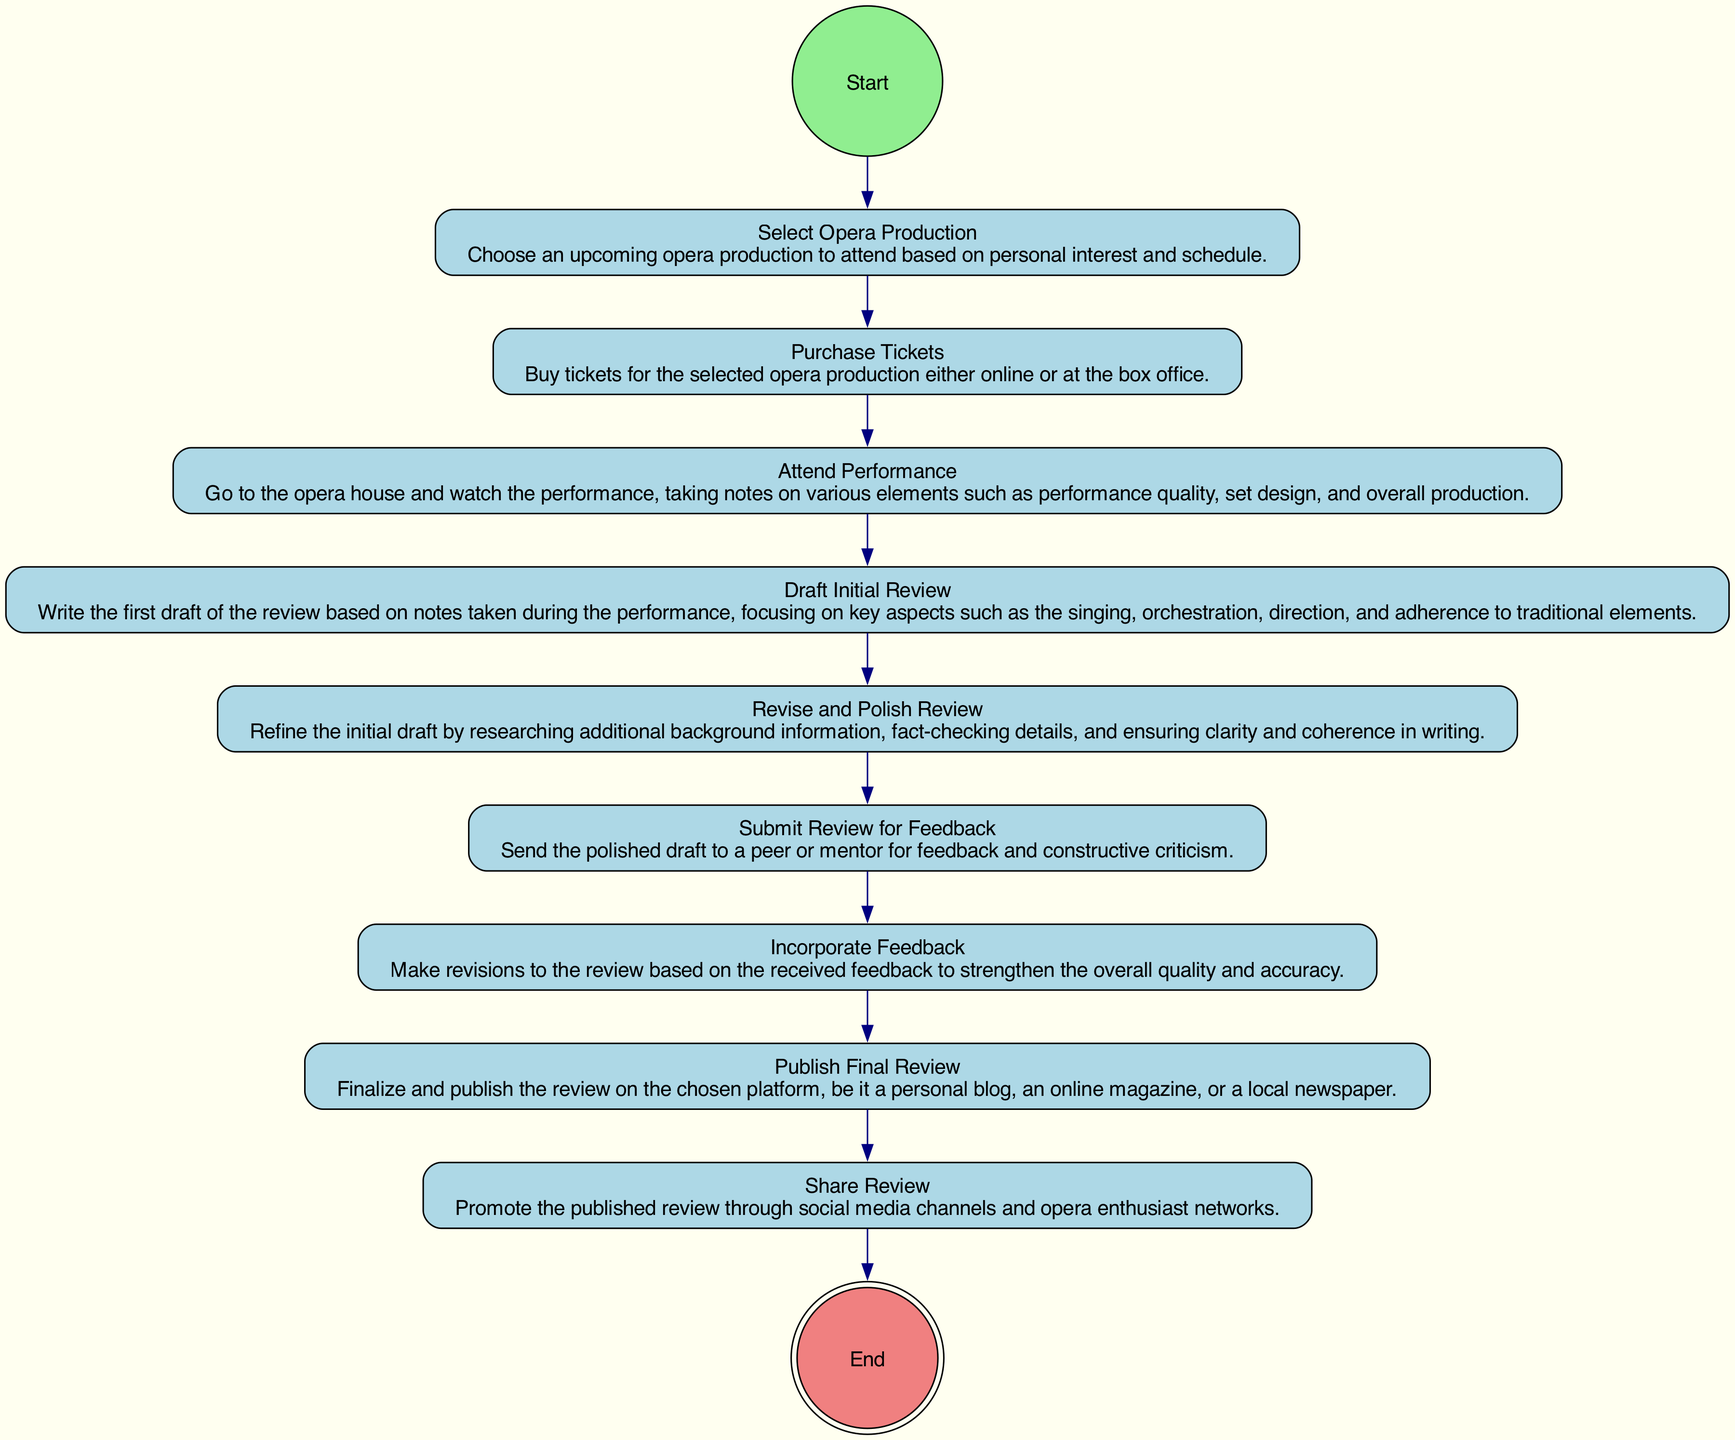What is the first activity in the diagram? The first activity listed in the diagram is "Select Opera Production" as it is connected directly from the "Start" node.
Answer: Select Opera Production How many total activities are represented in the diagram? By counting each unique activity node listed in the diagram, there are nine activities from "Select Opera Production" to "Share Review."
Answer: Nine What is the last activity before publishing the final review? The last activity preceding "Publish Final Review" is "Incorporate Feedback," which indicates actions to take before the final publication.
Answer: Incorporate Feedback Which activity follows after "Attend Performance"? The activity that follows "Attend Performance" is "Draft Initial Review," indicating the next step taken after attending the opera.
Answer: Draft Initial Review What two activities are directly connected to "Revise and Polish Review"? "Draft Initial Review" precedes "Revise and Polish Review," and "Submit Review for Feedback" comes directly after it, creating a sequential flow.
Answer: Draft Initial Review, Submit Review for Feedback What is the relationship between "Submit Review for Feedback" and "Incorporate Feedback"? "Submit Review for Feedback" leads to "Incorporate Feedback," meaning after feedback is received, it will influence the next steps taken in crafting the review.
Answer: Submit Review for Feedback leads to Incorporate Feedback Why is it important to "Revise and Polish Review"? This activity is essential as it allows for refining the initial draft, ensuring accuracy and clarity, and preparing for effective communication of the review.
Answer: To ensure clarity and coherence How does the diagram describe the flow from "Purchase Tickets" to "Share Review"? The diagram depicts a chronological flow starting from "Purchase Tickets" through various subsequent activities until reaching "Share Review," illustrating the complete process of review compilation.
Answer: A chronological flow from Purchase Tickets to Share Review 